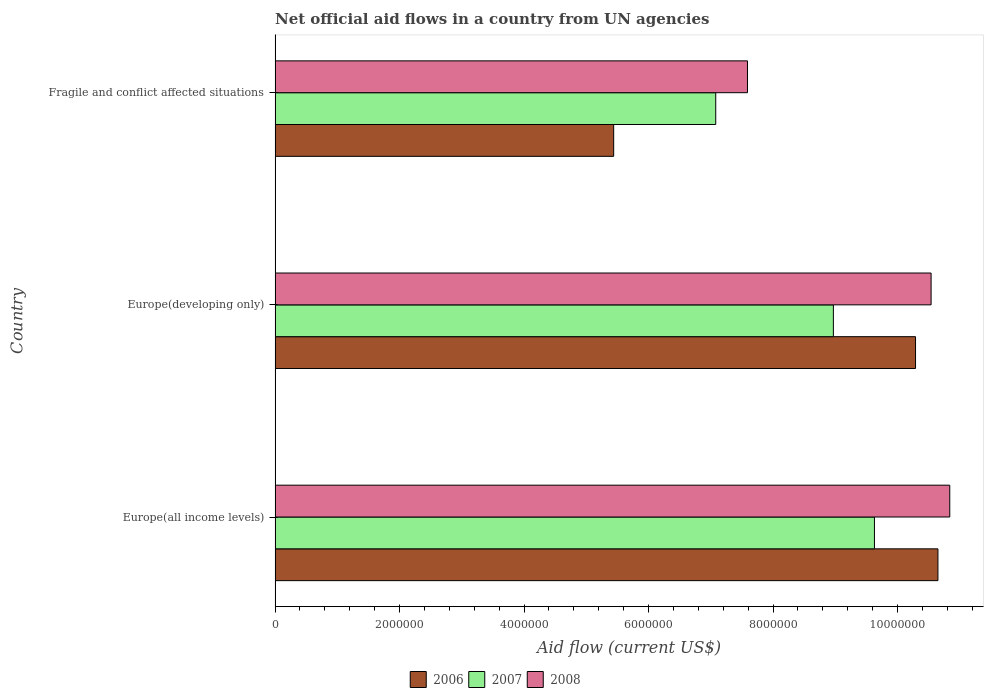How many groups of bars are there?
Your response must be concise. 3. Are the number of bars on each tick of the Y-axis equal?
Keep it short and to the point. Yes. What is the label of the 1st group of bars from the top?
Your answer should be compact. Fragile and conflict affected situations. In how many cases, is the number of bars for a given country not equal to the number of legend labels?
Your response must be concise. 0. What is the net official aid flow in 2007 in Europe(developing only)?
Make the answer very short. 8.97e+06. Across all countries, what is the maximum net official aid flow in 2008?
Make the answer very short. 1.08e+07. Across all countries, what is the minimum net official aid flow in 2008?
Your response must be concise. 7.59e+06. In which country was the net official aid flow in 2006 maximum?
Your response must be concise. Europe(all income levels). In which country was the net official aid flow in 2008 minimum?
Your answer should be compact. Fragile and conflict affected situations. What is the total net official aid flow in 2007 in the graph?
Make the answer very short. 2.57e+07. What is the difference between the net official aid flow in 2008 in Europe(all income levels) and that in Europe(developing only)?
Provide a succinct answer. 3.00e+05. What is the average net official aid flow in 2006 per country?
Make the answer very short. 8.79e+06. In how many countries, is the net official aid flow in 2006 greater than 9200000 US$?
Make the answer very short. 2. What is the ratio of the net official aid flow in 2008 in Europe(all income levels) to that in Fragile and conflict affected situations?
Make the answer very short. 1.43. Is the difference between the net official aid flow in 2008 in Europe(all income levels) and Europe(developing only) greater than the difference between the net official aid flow in 2006 in Europe(all income levels) and Europe(developing only)?
Provide a succinct answer. No. What is the difference between the highest and the lowest net official aid flow in 2007?
Give a very brief answer. 2.55e+06. In how many countries, is the net official aid flow in 2007 greater than the average net official aid flow in 2007 taken over all countries?
Your response must be concise. 2. What does the 1st bar from the top in Europe(developing only) represents?
Your answer should be very brief. 2008. What does the 2nd bar from the bottom in Europe(all income levels) represents?
Ensure brevity in your answer.  2007. Is it the case that in every country, the sum of the net official aid flow in 2007 and net official aid flow in 2006 is greater than the net official aid flow in 2008?
Make the answer very short. Yes. What is the difference between two consecutive major ticks on the X-axis?
Your response must be concise. 2.00e+06. Are the values on the major ticks of X-axis written in scientific E-notation?
Provide a succinct answer. No. Does the graph contain grids?
Your answer should be compact. No. How many legend labels are there?
Your response must be concise. 3. What is the title of the graph?
Provide a short and direct response. Net official aid flows in a country from UN agencies. Does "2006" appear as one of the legend labels in the graph?
Give a very brief answer. Yes. What is the Aid flow (current US$) of 2006 in Europe(all income levels)?
Provide a succinct answer. 1.06e+07. What is the Aid flow (current US$) in 2007 in Europe(all income levels)?
Provide a succinct answer. 9.63e+06. What is the Aid flow (current US$) of 2008 in Europe(all income levels)?
Your response must be concise. 1.08e+07. What is the Aid flow (current US$) in 2006 in Europe(developing only)?
Your answer should be compact. 1.03e+07. What is the Aid flow (current US$) in 2007 in Europe(developing only)?
Ensure brevity in your answer.  8.97e+06. What is the Aid flow (current US$) of 2008 in Europe(developing only)?
Your response must be concise. 1.05e+07. What is the Aid flow (current US$) in 2006 in Fragile and conflict affected situations?
Provide a succinct answer. 5.44e+06. What is the Aid flow (current US$) in 2007 in Fragile and conflict affected situations?
Your answer should be very brief. 7.08e+06. What is the Aid flow (current US$) of 2008 in Fragile and conflict affected situations?
Offer a terse response. 7.59e+06. Across all countries, what is the maximum Aid flow (current US$) of 2006?
Offer a very short reply. 1.06e+07. Across all countries, what is the maximum Aid flow (current US$) in 2007?
Give a very brief answer. 9.63e+06. Across all countries, what is the maximum Aid flow (current US$) in 2008?
Your answer should be very brief. 1.08e+07. Across all countries, what is the minimum Aid flow (current US$) in 2006?
Provide a succinct answer. 5.44e+06. Across all countries, what is the minimum Aid flow (current US$) in 2007?
Your answer should be very brief. 7.08e+06. Across all countries, what is the minimum Aid flow (current US$) in 2008?
Offer a terse response. 7.59e+06. What is the total Aid flow (current US$) in 2006 in the graph?
Your response must be concise. 2.64e+07. What is the total Aid flow (current US$) in 2007 in the graph?
Provide a short and direct response. 2.57e+07. What is the total Aid flow (current US$) in 2008 in the graph?
Your answer should be compact. 2.90e+07. What is the difference between the Aid flow (current US$) of 2006 in Europe(all income levels) and that in Europe(developing only)?
Your response must be concise. 3.60e+05. What is the difference between the Aid flow (current US$) in 2006 in Europe(all income levels) and that in Fragile and conflict affected situations?
Offer a terse response. 5.21e+06. What is the difference between the Aid flow (current US$) in 2007 in Europe(all income levels) and that in Fragile and conflict affected situations?
Your answer should be compact. 2.55e+06. What is the difference between the Aid flow (current US$) in 2008 in Europe(all income levels) and that in Fragile and conflict affected situations?
Provide a succinct answer. 3.25e+06. What is the difference between the Aid flow (current US$) of 2006 in Europe(developing only) and that in Fragile and conflict affected situations?
Give a very brief answer. 4.85e+06. What is the difference between the Aid flow (current US$) in 2007 in Europe(developing only) and that in Fragile and conflict affected situations?
Offer a terse response. 1.89e+06. What is the difference between the Aid flow (current US$) of 2008 in Europe(developing only) and that in Fragile and conflict affected situations?
Make the answer very short. 2.95e+06. What is the difference between the Aid flow (current US$) in 2006 in Europe(all income levels) and the Aid flow (current US$) in 2007 in Europe(developing only)?
Provide a succinct answer. 1.68e+06. What is the difference between the Aid flow (current US$) in 2006 in Europe(all income levels) and the Aid flow (current US$) in 2008 in Europe(developing only)?
Your answer should be compact. 1.10e+05. What is the difference between the Aid flow (current US$) of 2007 in Europe(all income levels) and the Aid flow (current US$) of 2008 in Europe(developing only)?
Offer a very short reply. -9.10e+05. What is the difference between the Aid flow (current US$) in 2006 in Europe(all income levels) and the Aid flow (current US$) in 2007 in Fragile and conflict affected situations?
Your response must be concise. 3.57e+06. What is the difference between the Aid flow (current US$) in 2006 in Europe(all income levels) and the Aid flow (current US$) in 2008 in Fragile and conflict affected situations?
Give a very brief answer. 3.06e+06. What is the difference between the Aid flow (current US$) of 2007 in Europe(all income levels) and the Aid flow (current US$) of 2008 in Fragile and conflict affected situations?
Keep it short and to the point. 2.04e+06. What is the difference between the Aid flow (current US$) in 2006 in Europe(developing only) and the Aid flow (current US$) in 2007 in Fragile and conflict affected situations?
Offer a very short reply. 3.21e+06. What is the difference between the Aid flow (current US$) of 2006 in Europe(developing only) and the Aid flow (current US$) of 2008 in Fragile and conflict affected situations?
Provide a short and direct response. 2.70e+06. What is the difference between the Aid flow (current US$) of 2007 in Europe(developing only) and the Aid flow (current US$) of 2008 in Fragile and conflict affected situations?
Give a very brief answer. 1.38e+06. What is the average Aid flow (current US$) of 2006 per country?
Offer a very short reply. 8.79e+06. What is the average Aid flow (current US$) of 2007 per country?
Give a very brief answer. 8.56e+06. What is the average Aid flow (current US$) in 2008 per country?
Keep it short and to the point. 9.66e+06. What is the difference between the Aid flow (current US$) in 2006 and Aid flow (current US$) in 2007 in Europe(all income levels)?
Keep it short and to the point. 1.02e+06. What is the difference between the Aid flow (current US$) in 2006 and Aid flow (current US$) in 2008 in Europe(all income levels)?
Your answer should be compact. -1.90e+05. What is the difference between the Aid flow (current US$) in 2007 and Aid flow (current US$) in 2008 in Europe(all income levels)?
Offer a terse response. -1.21e+06. What is the difference between the Aid flow (current US$) of 2006 and Aid flow (current US$) of 2007 in Europe(developing only)?
Offer a very short reply. 1.32e+06. What is the difference between the Aid flow (current US$) in 2007 and Aid flow (current US$) in 2008 in Europe(developing only)?
Provide a short and direct response. -1.57e+06. What is the difference between the Aid flow (current US$) of 2006 and Aid flow (current US$) of 2007 in Fragile and conflict affected situations?
Your answer should be very brief. -1.64e+06. What is the difference between the Aid flow (current US$) of 2006 and Aid flow (current US$) of 2008 in Fragile and conflict affected situations?
Your answer should be compact. -2.15e+06. What is the difference between the Aid flow (current US$) in 2007 and Aid flow (current US$) in 2008 in Fragile and conflict affected situations?
Offer a very short reply. -5.10e+05. What is the ratio of the Aid flow (current US$) of 2006 in Europe(all income levels) to that in Europe(developing only)?
Make the answer very short. 1.03. What is the ratio of the Aid flow (current US$) of 2007 in Europe(all income levels) to that in Europe(developing only)?
Your response must be concise. 1.07. What is the ratio of the Aid flow (current US$) in 2008 in Europe(all income levels) to that in Europe(developing only)?
Make the answer very short. 1.03. What is the ratio of the Aid flow (current US$) of 2006 in Europe(all income levels) to that in Fragile and conflict affected situations?
Make the answer very short. 1.96. What is the ratio of the Aid flow (current US$) in 2007 in Europe(all income levels) to that in Fragile and conflict affected situations?
Offer a terse response. 1.36. What is the ratio of the Aid flow (current US$) of 2008 in Europe(all income levels) to that in Fragile and conflict affected situations?
Your answer should be very brief. 1.43. What is the ratio of the Aid flow (current US$) in 2006 in Europe(developing only) to that in Fragile and conflict affected situations?
Give a very brief answer. 1.89. What is the ratio of the Aid flow (current US$) of 2007 in Europe(developing only) to that in Fragile and conflict affected situations?
Provide a short and direct response. 1.27. What is the ratio of the Aid flow (current US$) of 2008 in Europe(developing only) to that in Fragile and conflict affected situations?
Offer a terse response. 1.39. What is the difference between the highest and the second highest Aid flow (current US$) in 2007?
Your response must be concise. 6.60e+05. What is the difference between the highest and the lowest Aid flow (current US$) of 2006?
Make the answer very short. 5.21e+06. What is the difference between the highest and the lowest Aid flow (current US$) in 2007?
Offer a very short reply. 2.55e+06. What is the difference between the highest and the lowest Aid flow (current US$) of 2008?
Provide a succinct answer. 3.25e+06. 